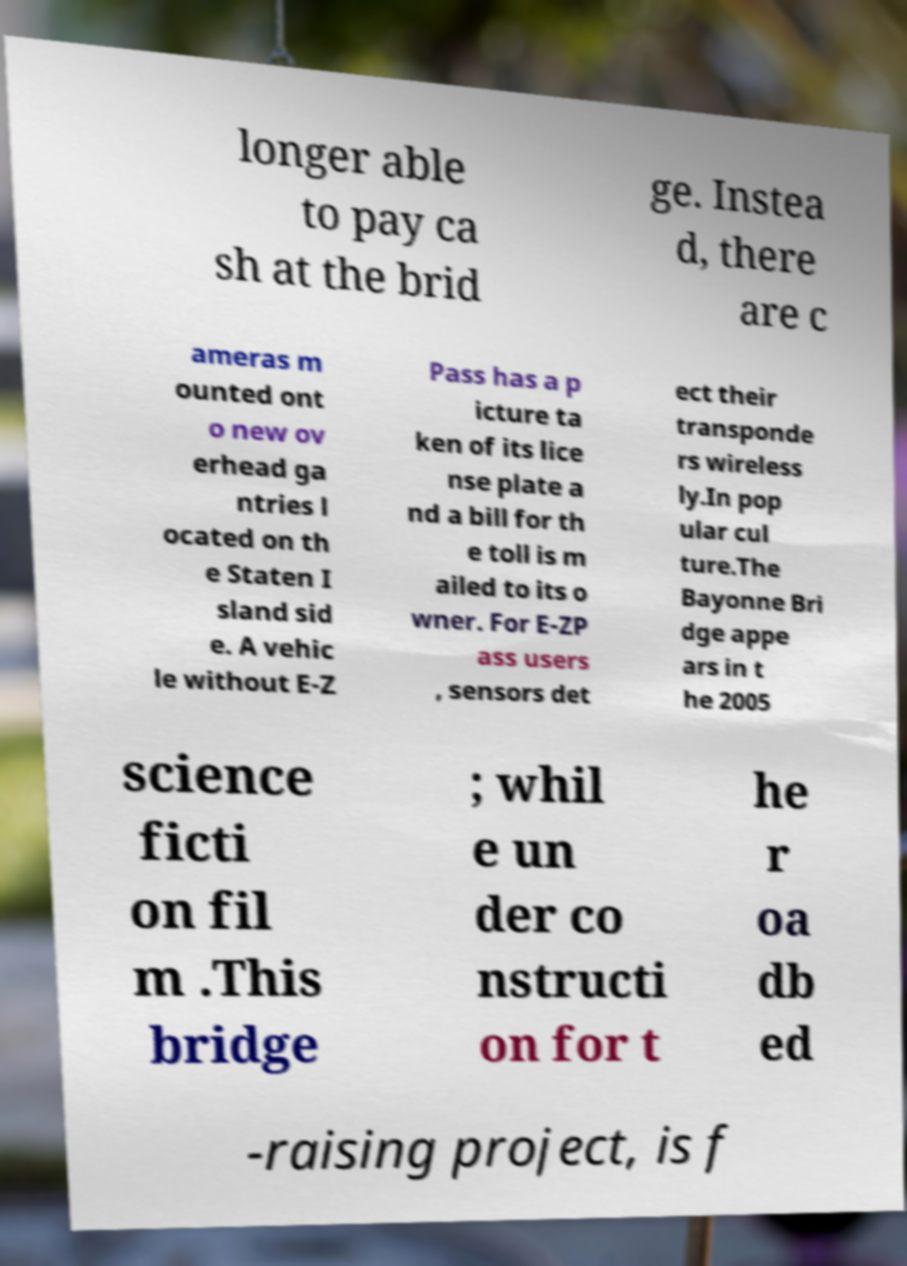For documentation purposes, I need the text within this image transcribed. Could you provide that? longer able to pay ca sh at the brid ge. Instea d, there are c ameras m ounted ont o new ov erhead ga ntries l ocated on th e Staten I sland sid e. A vehic le without E-Z Pass has a p icture ta ken of its lice nse plate a nd a bill for th e toll is m ailed to its o wner. For E-ZP ass users , sensors det ect their transponde rs wireless ly.In pop ular cul ture.The Bayonne Bri dge appe ars in t he 2005 science ficti on fil m .This bridge ; whil e un der co nstructi on for t he r oa db ed -raising project, is f 